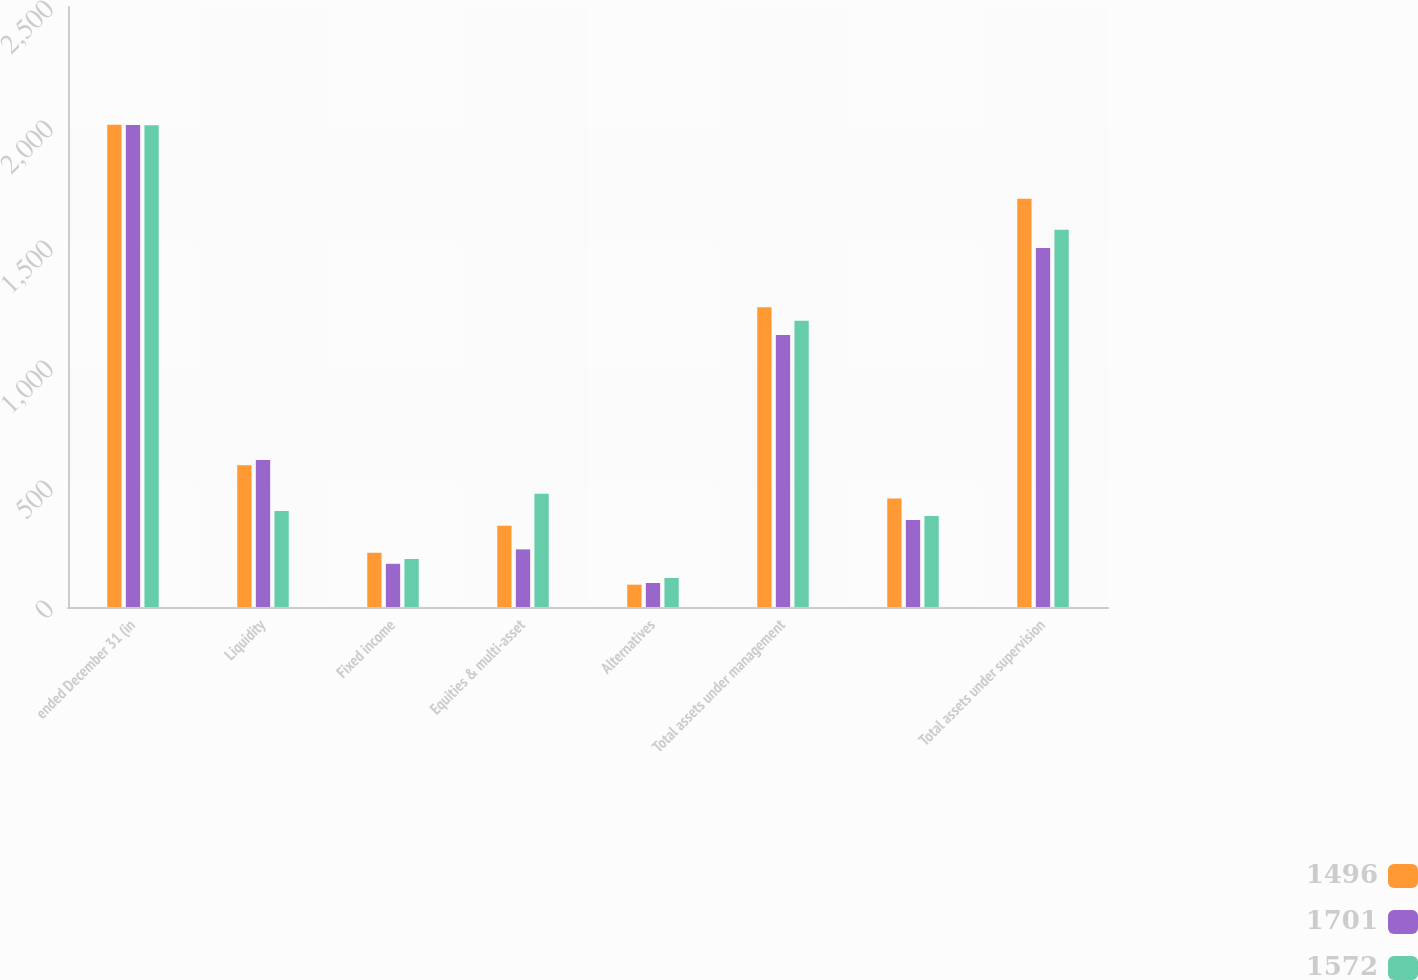Convert chart to OTSL. <chart><loc_0><loc_0><loc_500><loc_500><stacked_bar_chart><ecel><fcel>ended December 31 (in<fcel>Liquidity<fcel>Fixed income<fcel>Equities & multi-asset<fcel>Alternatives<fcel>Total assets under management<fcel>Unnamed: 7<fcel>Total assets under supervision<nl><fcel>1496<fcel>2009<fcel>591<fcel>226<fcel>339<fcel>93<fcel>1249<fcel>452<fcel>1701<nl><fcel>1701<fcel>2008<fcel>613<fcel>180<fcel>240<fcel>100<fcel>1133<fcel>363<fcel>1496<nl><fcel>1572<fcel>2007<fcel>400<fcel>200<fcel>472<fcel>121<fcel>1193<fcel>379<fcel>1572<nl></chart> 